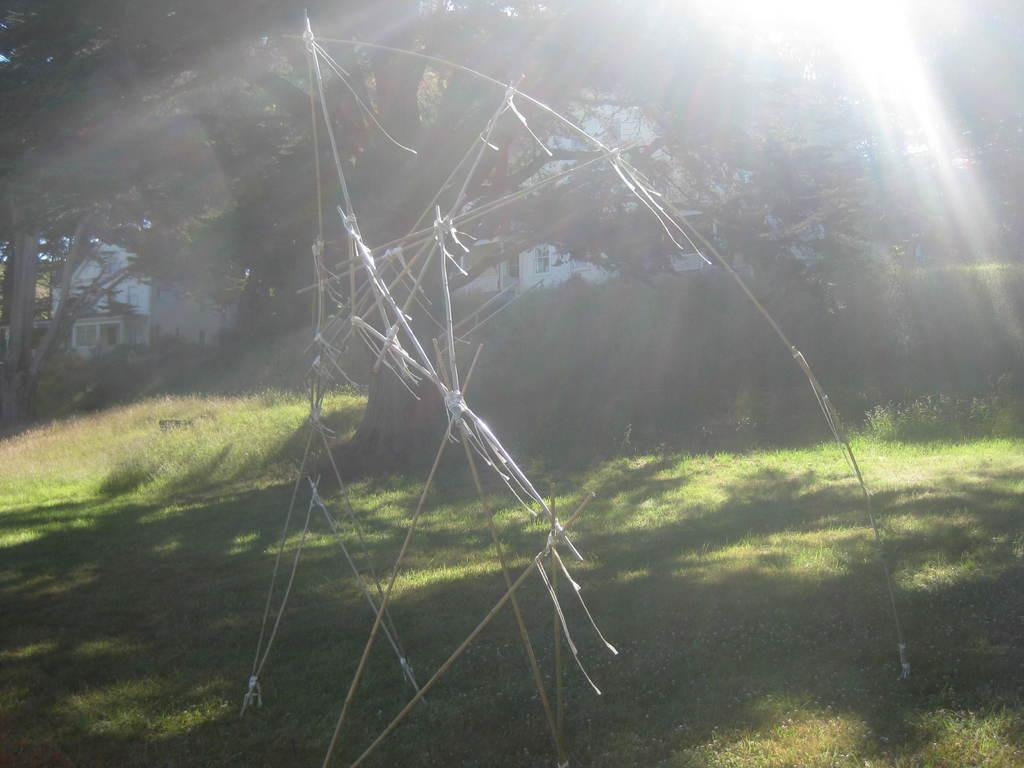What objects can be seen in the image? There are sticks in the image. What can be seen in the background of the image? There are trees and buildings in the background of the image. What type of ground surface is visible at the bottom of the image? Grass is visible at the bottom of the image. What is the source of light at the top of the image? There is a light at the top of the image. How many rabbits are hiding behind the trees in the image? There are no rabbits present in the image; only sticks, trees, buildings, grass, and a light can be seen. 